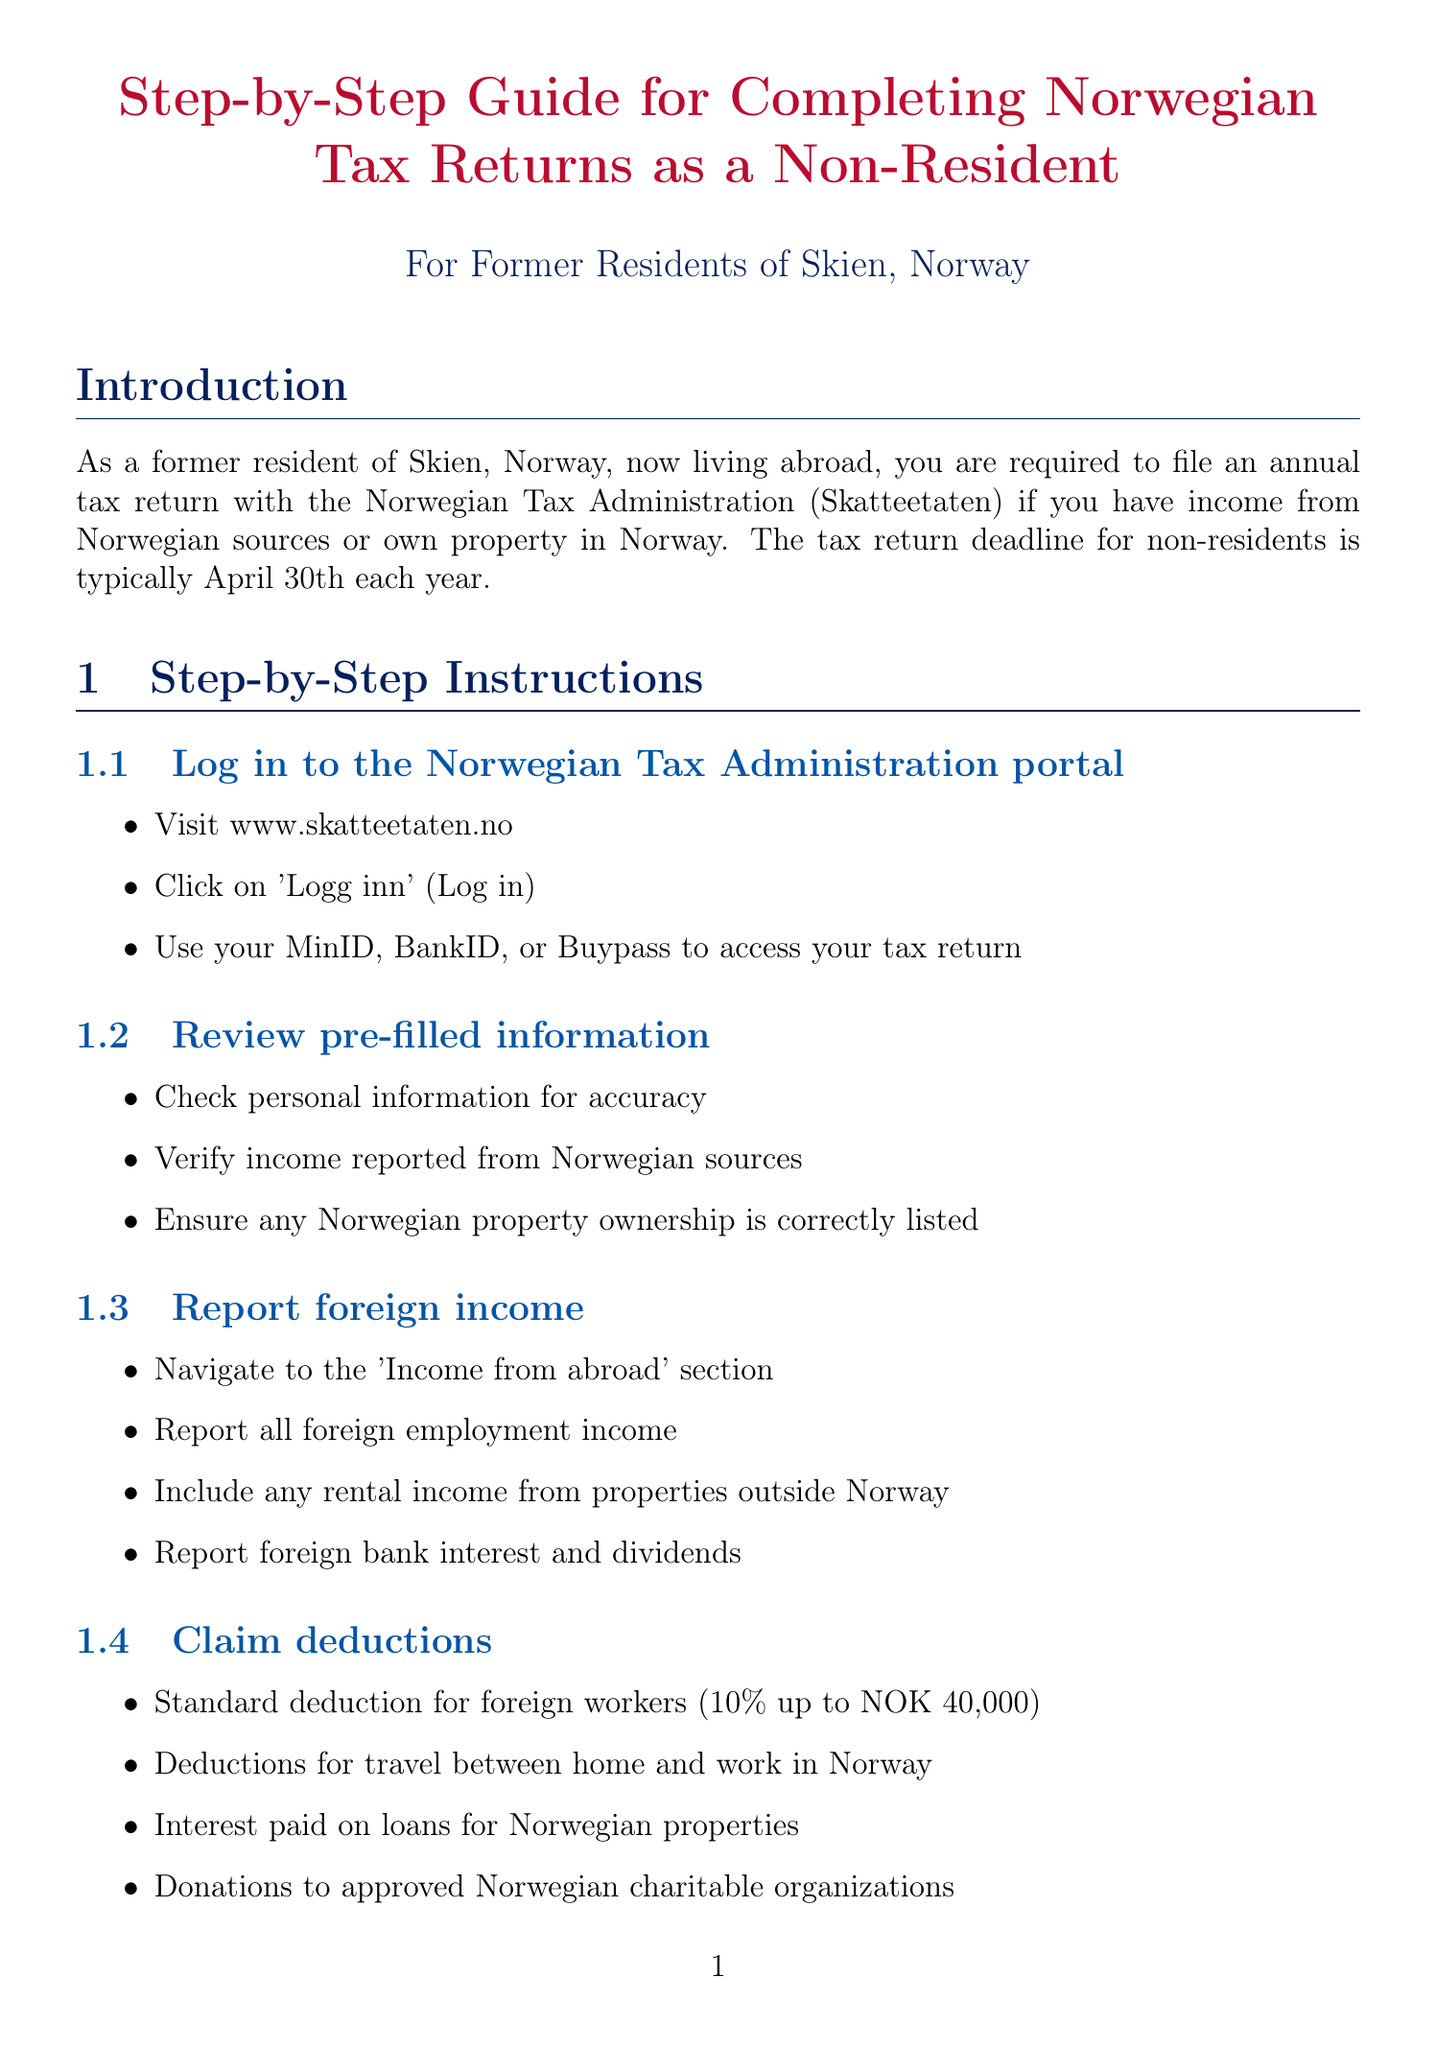What is the tax return deadline for non-residents? The document specifies that the tax return deadline for non-residents is typically April 30th each year.
Answer: April 30th What percentage is the standard deduction for foreign workers? The manual states that the standard deduction for foreign workers is 10% up to NOK 40,000.
Answer: 10% What are the phone contact details for Skatteetaten? The document includes contact information and states the phone number for Skatteetaten is +47 22 07 70 00.
Answer: +47 22 07 70 00 Which section do you navigate to, to report foreign income? According to the guide, you should navigate to the 'Income from abroad' section to report foreign income.
Answer: Income from abroad What is one common deduction listed in the document? The document provides a list of common deductions and includes personal allowance (personfradrag) as one of them.
Answer: Personal allowance What is the first step for completing the tax return? The first step mentioned in the guide is to log in to the Norwegian Tax Administration portal.
Answer: Log in to the Norwegian Tax Administration portal How long should you keep relevant documents and receipts? The reminders section indicates that you should keep all relevant documents and receipts for at least 5 years.
Answer: 5 years When should you notify Skatteetaten of changes? The reminders section advises to notify Skatteetaten of any changes in your residency status.
Answer: Changes in residency status What is required to apply for tax treaty benefits? The document states that you need to check if a tax treaty exists between Norway and your current country of residence to apply for tax treaty benefits.
Answer: Check tax treaty existence 